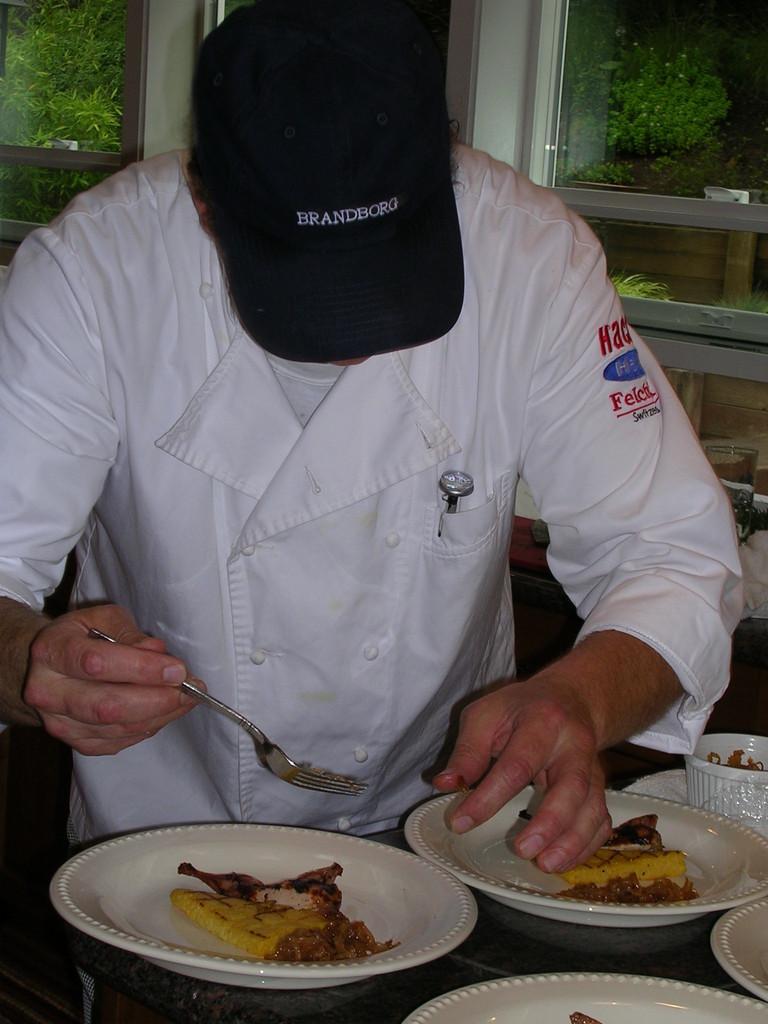How would you summarize this image in a sentence or two? In this image there is a person wearing a cap is holding a fork in his hand, in front of the person on the table there are two plates, in each plate there are some food items, behind the person there is a glass window, behind the window there are trees. 